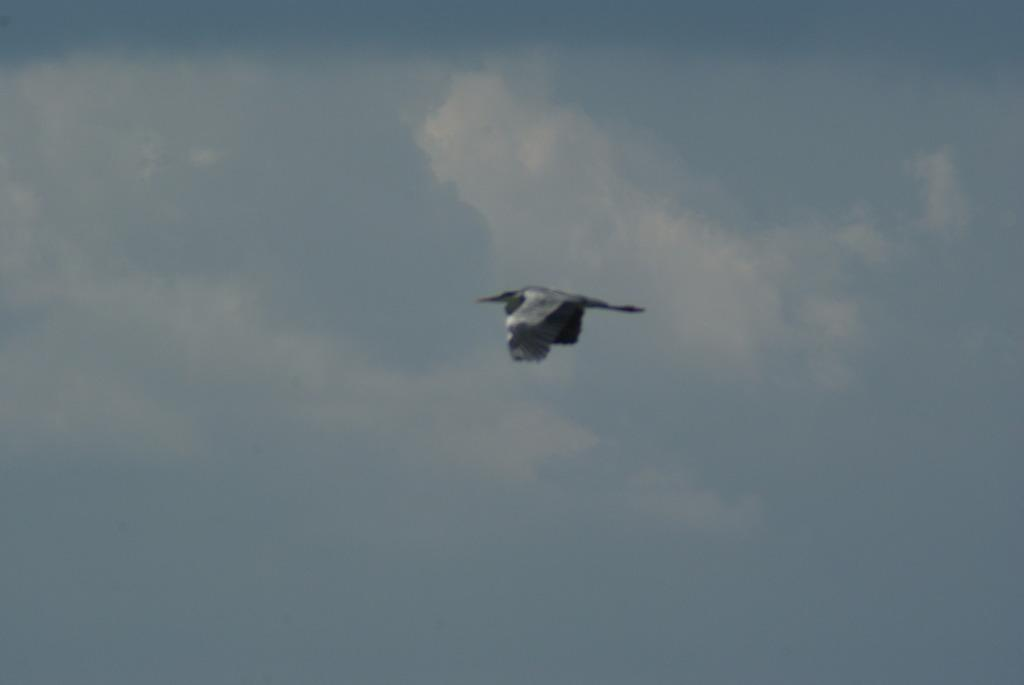What type of animal can be seen in the image? There is a bird in the image. What is the bird doing in the image? The bird is flying in the air. What can be seen in the background of the image? The sky is visible in the background of the image. What is the bird's opinion on the family in the image? There is no family present in the image, and therefore no opinion can be attributed to the bird. 